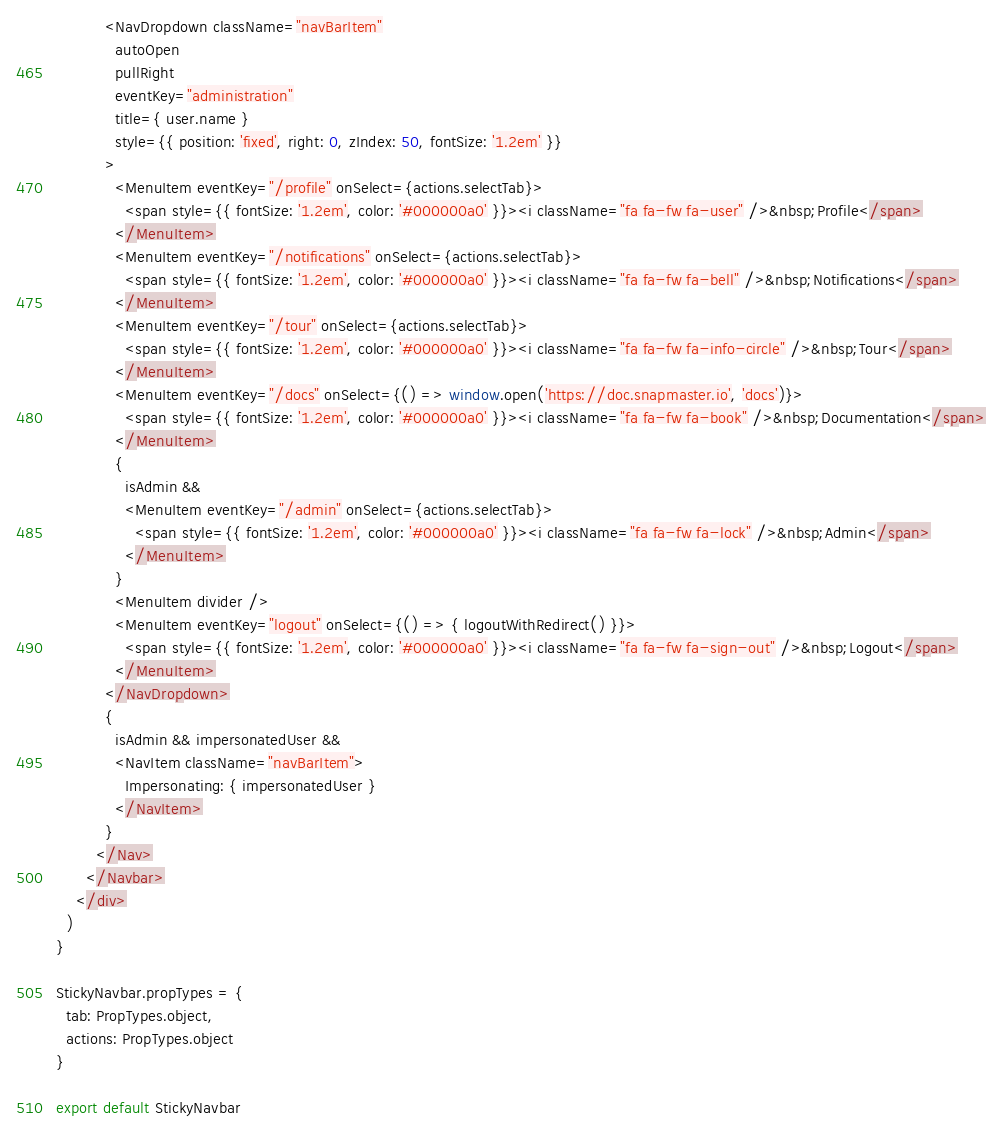<code> <loc_0><loc_0><loc_500><loc_500><_JavaScript_>          <NavDropdown className="navBarItem" 
            autoOpen
            pullRight
            eventKey="administration"
            title={ user.name }
            style={{ position: 'fixed', right: 0, zIndex: 50, fontSize: '1.2em' }}
          >
            <MenuItem eventKey="/profile" onSelect={actions.selectTab}>
              <span style={{ fontSize: '1.2em', color: '#000000a0' }}><i className="fa fa-fw fa-user" />&nbsp;Profile</span>
            </MenuItem>
            <MenuItem eventKey="/notifications" onSelect={actions.selectTab}>
              <span style={{ fontSize: '1.2em', color: '#000000a0' }}><i className="fa fa-fw fa-bell" />&nbsp;Notifications</span>
            </MenuItem>
            <MenuItem eventKey="/tour" onSelect={actions.selectTab}>
              <span style={{ fontSize: '1.2em', color: '#000000a0' }}><i className="fa fa-fw fa-info-circle" />&nbsp;Tour</span>
            </MenuItem>
            <MenuItem eventKey="/docs" onSelect={() => window.open('https://doc.snapmaster.io', 'docs')}>
              <span style={{ fontSize: '1.2em', color: '#000000a0' }}><i className="fa fa-fw fa-book" />&nbsp;Documentation</span>
            </MenuItem>
            {
              isAdmin && 
              <MenuItem eventKey="/admin" onSelect={actions.selectTab}>
                <span style={{ fontSize: '1.2em', color: '#000000a0' }}><i className="fa fa-fw fa-lock" />&nbsp;Admin</span>
              </MenuItem>
            }
            <MenuItem divider />
            <MenuItem eventKey="logout" onSelect={() => { logoutWithRedirect() }}>
              <span style={{ fontSize: '1.2em', color: '#000000a0' }}><i className="fa fa-fw fa-sign-out" />&nbsp;Logout</span>
            </MenuItem>
          </NavDropdown>
          {
            isAdmin && impersonatedUser &&
            <NavItem className="navBarItem">
              Impersonating: { impersonatedUser }
            </NavItem>
          }
        </Nav>
      </Navbar>
    </div>
  )
}

StickyNavbar.propTypes = {
  tab: PropTypes.object,
  actions: PropTypes.object
}

export default StickyNavbar</code> 